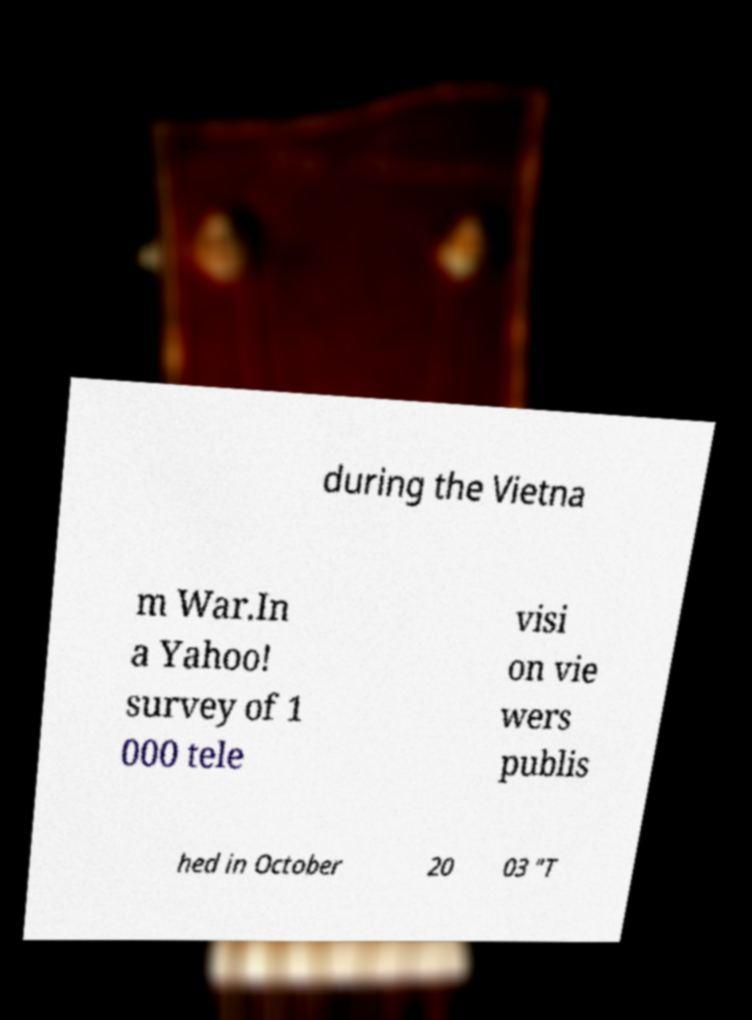For documentation purposes, I need the text within this image transcribed. Could you provide that? during the Vietna m War.In a Yahoo! survey of 1 000 tele visi on vie wers publis hed in October 20 03 "T 